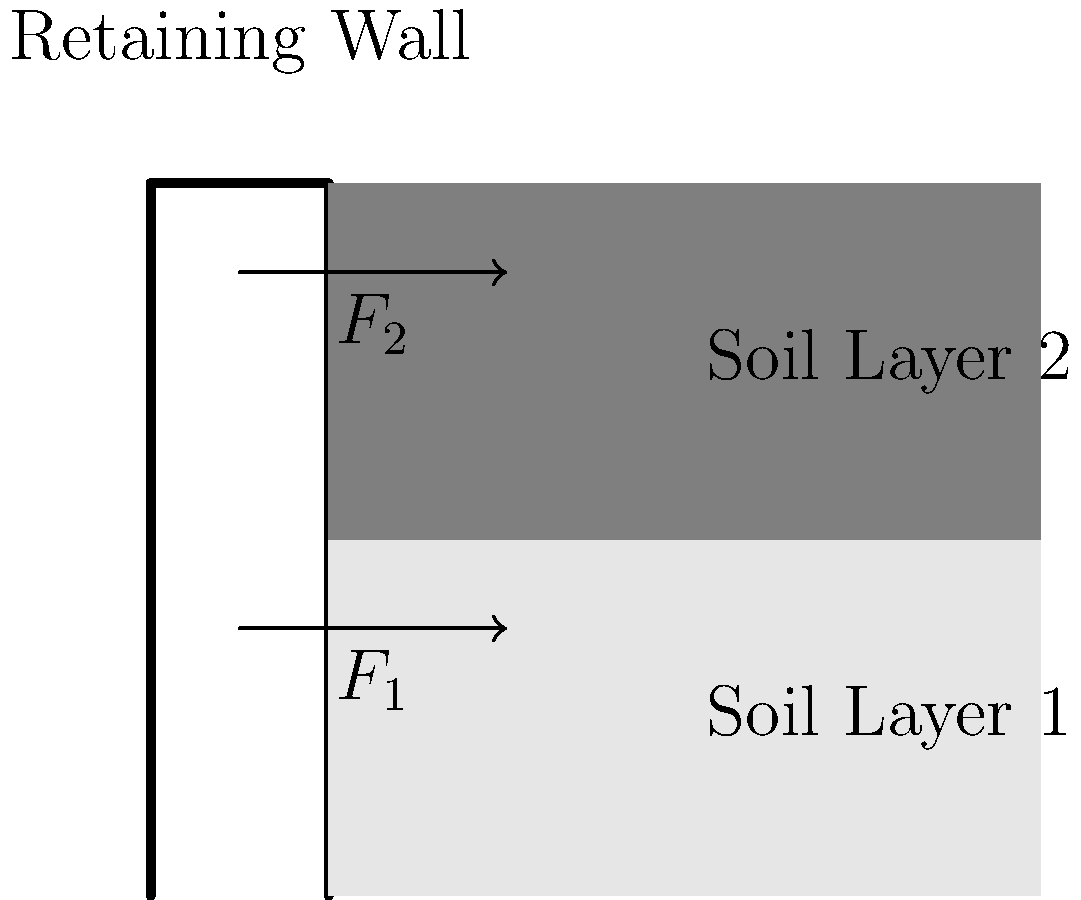A retaining wall is subject to lateral earth pressures from two different soil layers, as shown in the diagram. The force exerted by Soil Layer 1 is $F_1 = 50$ kN/m, and the force exerted by Soil Layer 2 is $F_2 = 30$ kN/m. If the wall is 4 meters high, calculate the total overturning moment about the base of the wall. To calculate the total overturning moment, we need to follow these steps:

1) Identify the forces: 
   $F_1 = 50$ kN/m (from Soil Layer 1)
   $F_2 = 30$ kN/m (from Soil Layer 2)

2) Determine the point of application for each force:
   - $F_1$ acts at 1/3 of the height of Soil Layer 1 from the base
   - $F_2$ acts at 1/3 of the height of Soil Layer 2 from the top of Soil Layer 1

3) Calculate the moment arm for each force:
   - For $F_1$: $1/3 * 2\text{m} = 0.67\text{m}$
   - For $F_2$: $2\text{m} + 1/3 * 2\text{m} = 2.67\text{m}$

4) Calculate the moment for each force:
   - Moment from $F_1 = 50\text{ kN/m} * 0.67\text{m} = 33.5\text{ kN·m/m}$
   - Moment from $F_2 = 30\text{ kN/m} * 2.67\text{m} = 80.1\text{ kN·m/m}$

5) Sum up the moments to get the total overturning moment:
   Total Moment = $33.5\text{ kN·m/m} + 80.1\text{ kN·m/m} = 113.6\text{ kN·m/m}$
Answer: 113.6 kN·m/m 